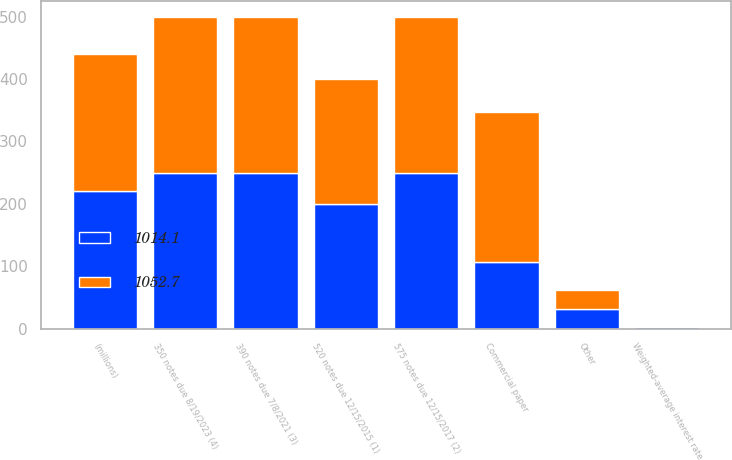Convert chart. <chart><loc_0><loc_0><loc_500><loc_500><stacked_bar_chart><ecel><fcel>(millions)<fcel>Commercial paper<fcel>Other<fcel>Weighted-average interest rate<fcel>520 notes due 12/15/2015 (1)<fcel>575 notes due 12/15/2017 (2)<fcel>390 notes due 7/8/2021 (3)<fcel>350 notes due 8/19/2023 (4)<nl><fcel>1014.1<fcel>219.7<fcel>107.5<fcel>32<fcel>2.2<fcel>200<fcel>250<fcel>250<fcel>250<nl><fcel>1052.7<fcel>219.7<fcel>239.4<fcel>30.2<fcel>1.3<fcel>200<fcel>250<fcel>250<fcel>250<nl></chart> 